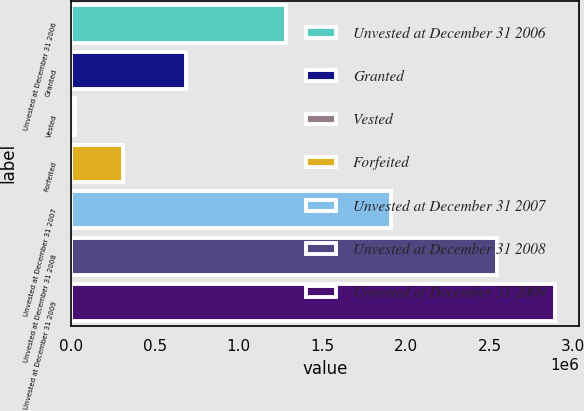Convert chart. <chart><loc_0><loc_0><loc_500><loc_500><bar_chart><fcel>Unvested at December 31 2006<fcel>Granted<fcel>Vested<fcel>Forfeited<fcel>Unvested at December 31 2007<fcel>Unvested at December 31 2008<fcel>Unvested at December 31 2009<nl><fcel>1.28574e+06<fcel>684210<fcel>22558<fcel>309416<fcel>1.91345e+06<fcel>2.5459e+06<fcel>2.89114e+06<nl></chart> 